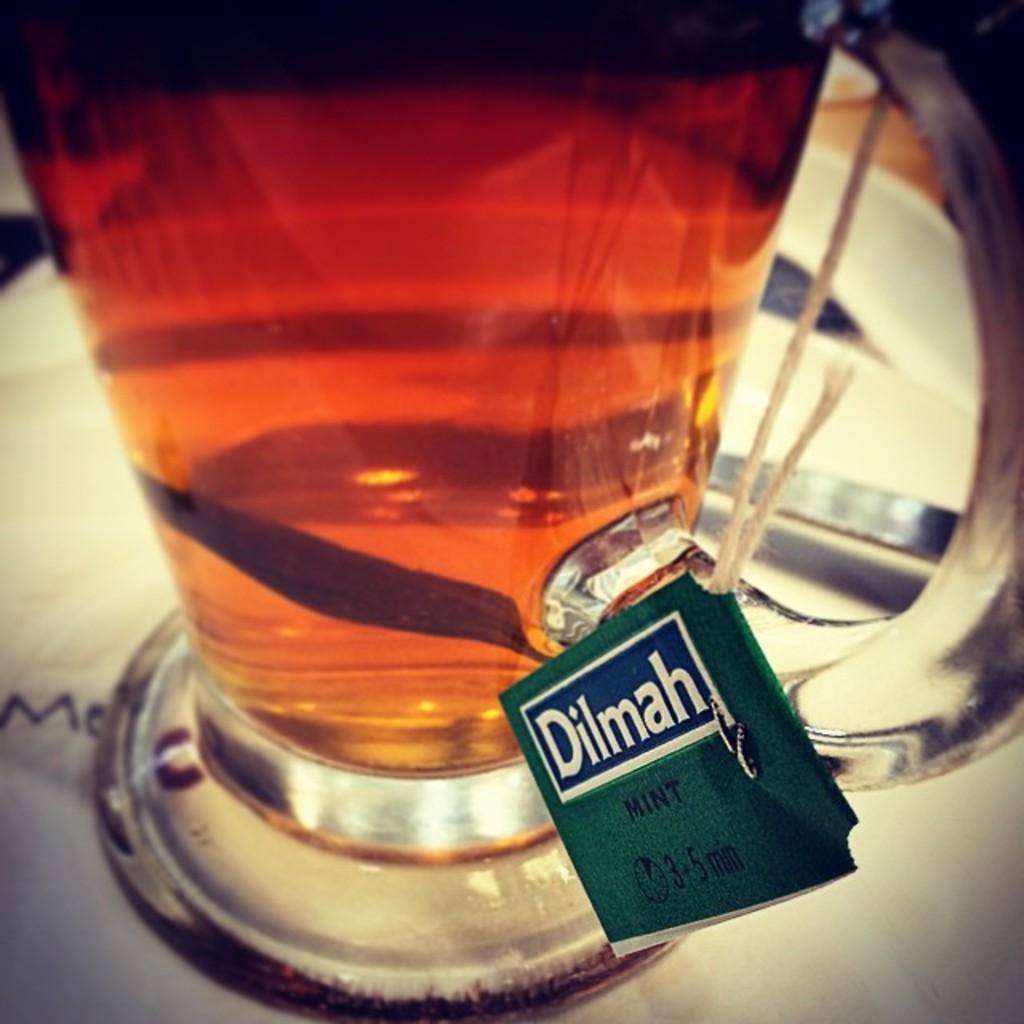How long should you steep this tea?
Your answer should be compact. 3-5 minutes. What is the brand name of this tea?
Give a very brief answer. Dilmah. 